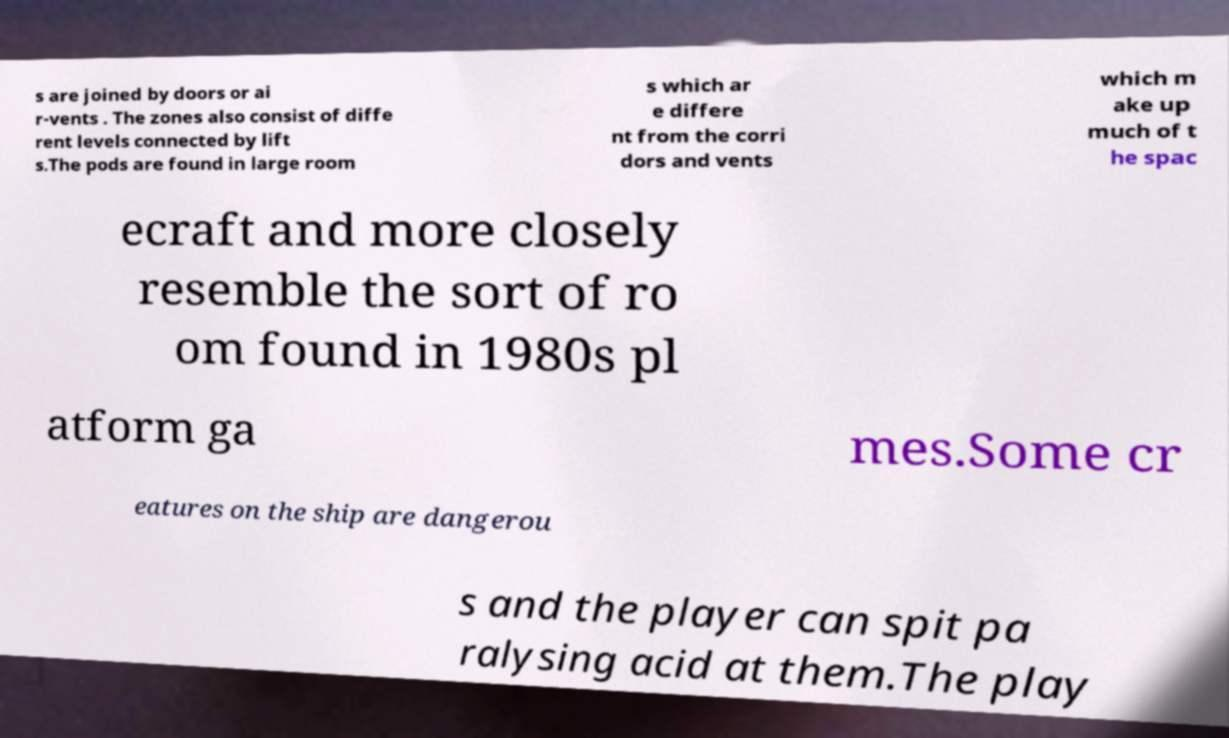Please read and relay the text visible in this image. What does it say? s are joined by doors or ai r-vents . The zones also consist of diffe rent levels connected by lift s.The pods are found in large room s which ar e differe nt from the corri dors and vents which m ake up much of t he spac ecraft and more closely resemble the sort of ro om found in 1980s pl atform ga mes.Some cr eatures on the ship are dangerou s and the player can spit pa ralysing acid at them.The play 